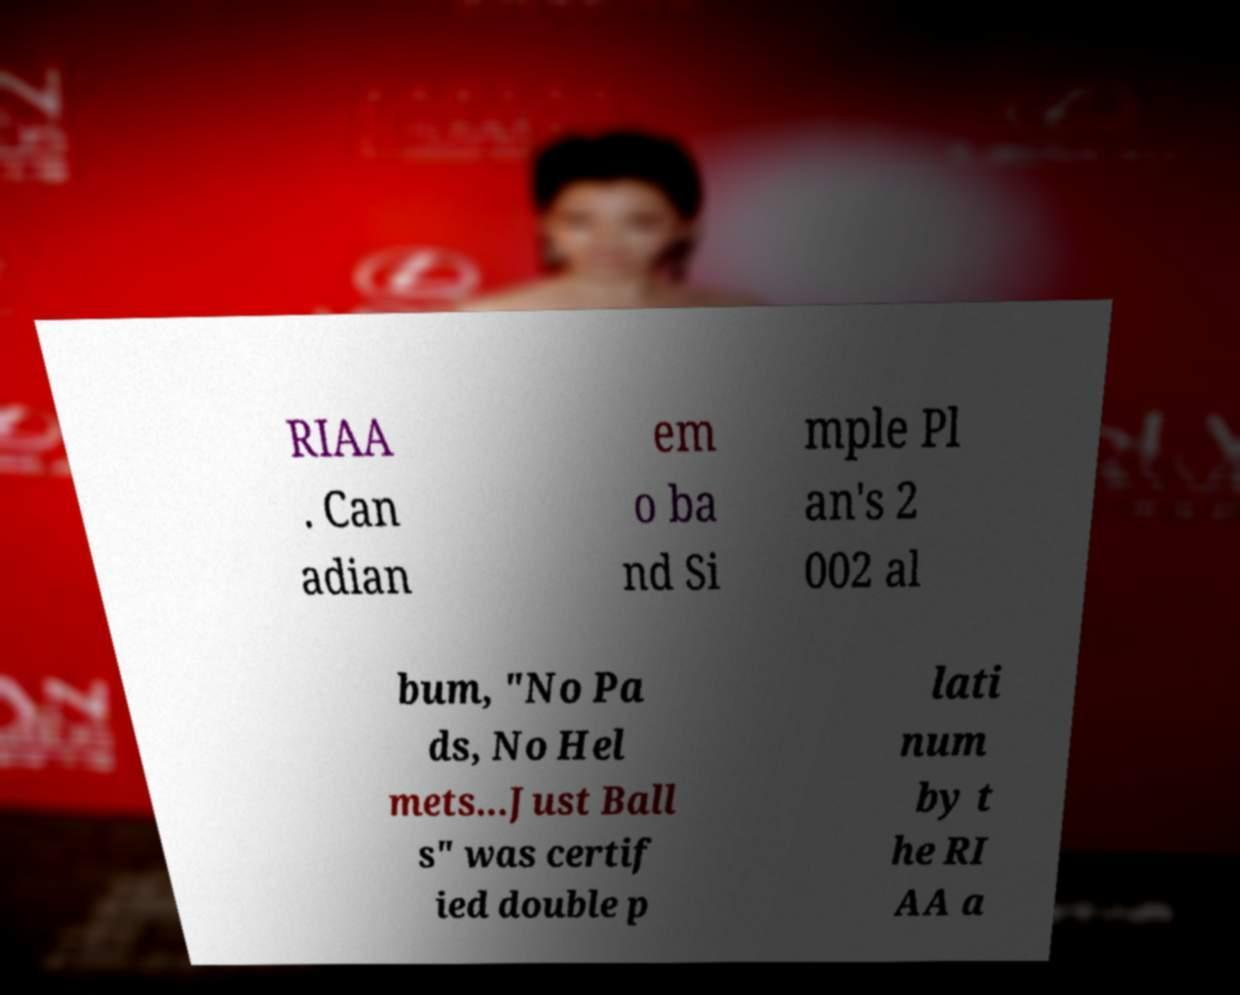What messages or text are displayed in this image? I need them in a readable, typed format. RIAA . Can adian em o ba nd Si mple Pl an's 2 002 al bum, "No Pa ds, No Hel mets...Just Ball s" was certif ied double p lati num by t he RI AA a 